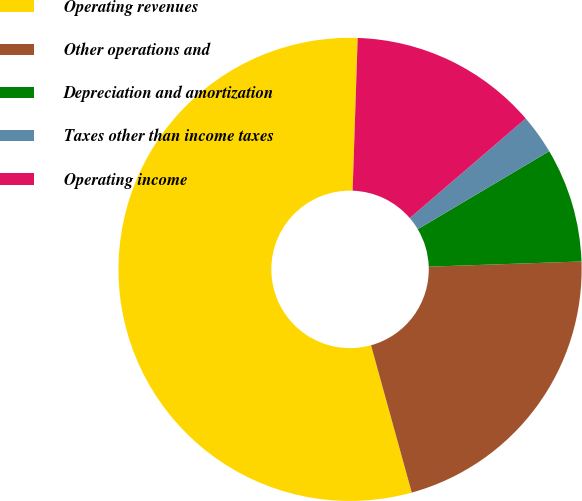<chart> <loc_0><loc_0><loc_500><loc_500><pie_chart><fcel>Operating revenues<fcel>Other operations and<fcel>Depreciation and amortization<fcel>Taxes other than income taxes<fcel>Operating income<nl><fcel>54.82%<fcel>21.25%<fcel>7.98%<fcel>2.77%<fcel>13.18%<nl></chart> 